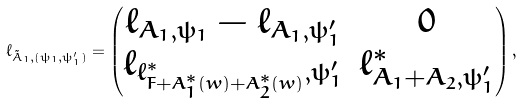<formula> <loc_0><loc_0><loc_500><loc_500>\ell _ { \tilde { A } _ { 1 } , ( \psi _ { 1 } , \psi _ { 1 } ^ { \prime } ) } = \begin{pmatrix} \ell _ { A _ { 1 } , \psi _ { 1 } } - \ell _ { A _ { 1 } , \psi _ { 1 } ^ { \prime } } & 0 \\ \ell _ { \ell ^ { * } _ { F + A _ { 1 } ^ { * } ( w ) + A ^ { * } _ { 2 } ( w ) } , \psi _ { 1 } ^ { \prime } } & \ell ^ { * } _ { A _ { 1 } + A _ { 2 } , \psi _ { 1 } ^ { \prime } } \end{pmatrix} ,</formula> 